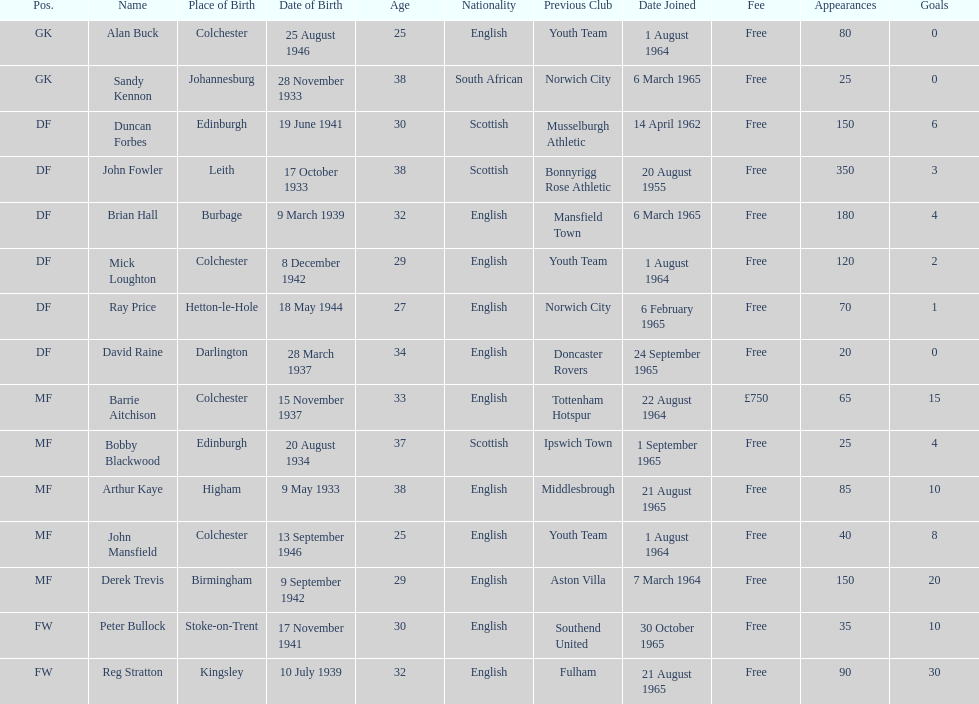Which player is the oldest? Arthur Kaye. Parse the table in full. {'header': ['Pos.', 'Name', 'Place of Birth', 'Date of Birth', 'Age', 'Nationality', 'Previous Club', 'Date Joined', 'Fee', 'Appearances', 'Goals'], 'rows': [['GK', 'Alan Buck', 'Colchester', '25 August 1946', '25', 'English', 'Youth Team', '1 August 1964', 'Free', '80', '0'], ['GK', 'Sandy Kennon', 'Johannesburg', '28 November 1933', '38', 'South African', 'Norwich City', '6 March 1965', 'Free', '25', '0'], ['DF', 'Duncan Forbes', 'Edinburgh', '19 June 1941', '30', 'Scottish', 'Musselburgh Athletic', '14 April 1962', 'Free', '150', '6'], ['DF', 'John Fowler', 'Leith', '17 October 1933', '38', 'Scottish', 'Bonnyrigg Rose Athletic', '20 August 1955', 'Free', '350', '3'], ['DF', 'Brian Hall', 'Burbage', '9 March 1939', '32', 'English', 'Mansfield Town', '6 March 1965', 'Free', '180', '4'], ['DF', 'Mick Loughton', 'Colchester', '8 December 1942', '29', 'English', 'Youth Team', '1 August 1964', 'Free', '120', '2'], ['DF', 'Ray Price', 'Hetton-le-Hole', '18 May 1944', '27', 'English', 'Norwich City', '6 February 1965', 'Free', '70', '1'], ['DF', 'David Raine', 'Darlington', '28 March 1937', '34', 'English', 'Doncaster Rovers', '24 September 1965', 'Free', '20', '0'], ['MF', 'Barrie Aitchison', 'Colchester', '15 November 1937', '33', 'English', 'Tottenham Hotspur', '22 August 1964', '£750', '65', '15'], ['MF', 'Bobby Blackwood', 'Edinburgh', '20 August 1934', '37', 'Scottish', 'Ipswich Town', '1 September 1965', 'Free', '25', '4'], ['MF', 'Arthur Kaye', 'Higham', '9 May 1933', '38', 'English', 'Middlesbrough', '21 August 1965', 'Free', '85', '10'], ['MF', 'John Mansfield', 'Colchester', '13 September 1946', '25', 'English', 'Youth Team', '1 August 1964', 'Free', '40', '8'], ['MF', 'Derek Trevis', 'Birmingham', '9 September 1942', '29', 'English', 'Aston Villa', '7 March 1964', 'Free', '150', '20'], ['FW', 'Peter Bullock', 'Stoke-on-Trent', '17 November 1941', '30', 'English', 'Southend United', '30 October 1965', 'Free', '35', '10'], ['FW', 'Reg Stratton', 'Kingsley', '10 July 1939', '32', 'English', 'Fulham', '21 August 1965', 'Free', '90', '30']]} 